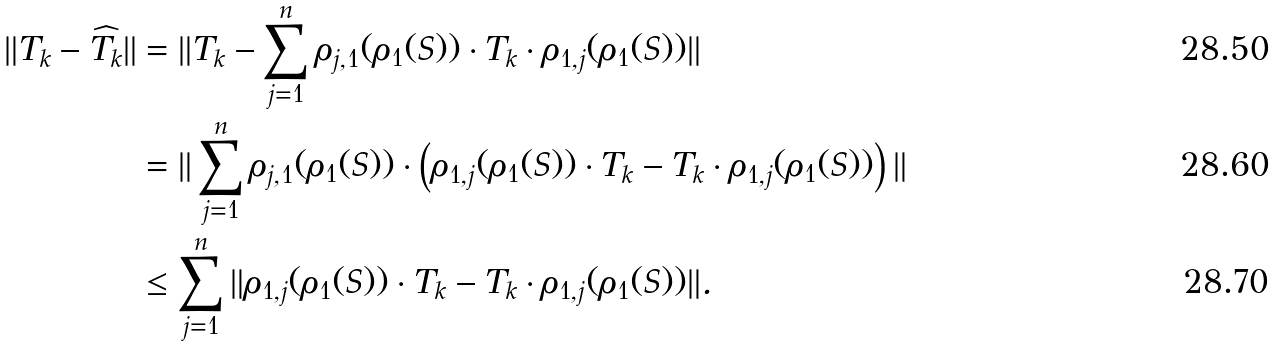Convert formula to latex. <formula><loc_0><loc_0><loc_500><loc_500>\| T _ { k } - \widehat { T _ { k } } \| & = \| T _ { k } - \sum _ { j = 1 } ^ { n } \rho _ { j , 1 } ( \rho _ { 1 } ( S ) ) \cdot T _ { k } \cdot \rho _ { 1 , j } ( \rho _ { 1 } ( S ) ) \| \\ & = \| \sum _ { j = 1 } ^ { n } \rho _ { j , 1 } ( \rho _ { 1 } ( S ) ) \cdot \left ( \rho _ { 1 , j } ( \rho _ { 1 } ( S ) ) \cdot T _ { k } - T _ { k } \cdot \rho _ { 1 , j } ( \rho _ { 1 } ( S ) ) \right ) \| \\ & \leq \sum _ { j = 1 } ^ { n } \| \rho _ { 1 , j } ( \rho _ { 1 } ( S ) ) \cdot T _ { k } - T _ { k } \cdot \rho _ { 1 , j } ( \rho _ { 1 } ( S ) ) \| .</formula> 